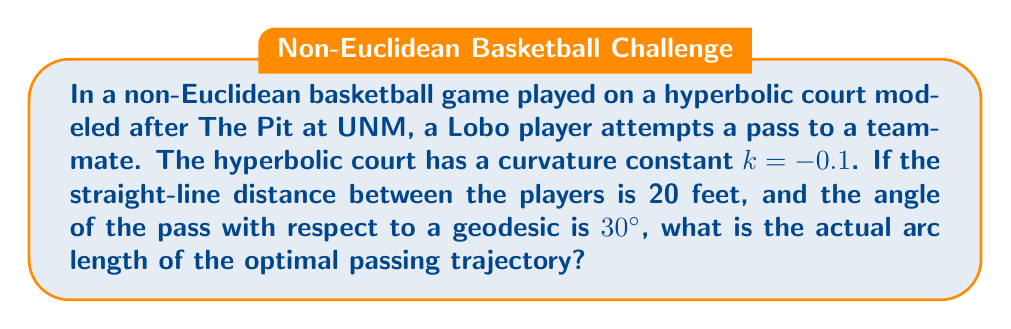What is the answer to this math problem? Let's approach this step-by-step:

1) In hyperbolic geometry, we use the hyperbolic law of cosines to relate distances and angles. The formula is:

   $$\cosh(kd) = \cosh(ka)\cosh(kb) - \sinh(ka)\sinh(kb)\cos(C)$$

   Where $d$ is the length of the optimal path, $a$ and $b$ are the geodesic distances from the players to the point where the pass intersects the geodesic, and $C$ is the angle between these geodesics.

2) We're given that the straight-line distance is 20 feet. In hyperbolic geometry, this corresponds to the chord of the arc. The relationship between chord length $c$ and arc length $d$ is:

   $$c = \frac{2}{k} \sinh(\frac{kd}{2})$$

3) Substituting our values:

   $$20 = \frac{2}{-0.1} \sinh(\frac{-0.1d}{2})$$

4) Solving for $d$:

   $$\sinh(\frac{-0.1d}{2}) = -1$$
   $$\frac{-0.1d}{2} = \arcsinh(-1)$$
   $$d = 20\arcsinh(1) \approx 23.14 \text{ feet}$$

5) This is the length of the geodesic between the players. However, the pass is at a $30°$ angle to this geodesic.

6) In hyperbolic geometry, the optimal path is not a straight line but a hypercycle. The length of this hypercycle can be approximated using the formula:

   $$l \approx d\sec(\theta)$$

   Where $l$ is the length of the hypercycle, $d$ is the geodesic distance, and $\theta$ is the angle with the geodesic.

7) Substituting our values:

   $$l \approx 23.14 \sec(30°) \approx 26.72 \text{ feet}$$

Therefore, the optimal passing trajectory is approximately 26.72 feet long.
Answer: 26.72 feet 